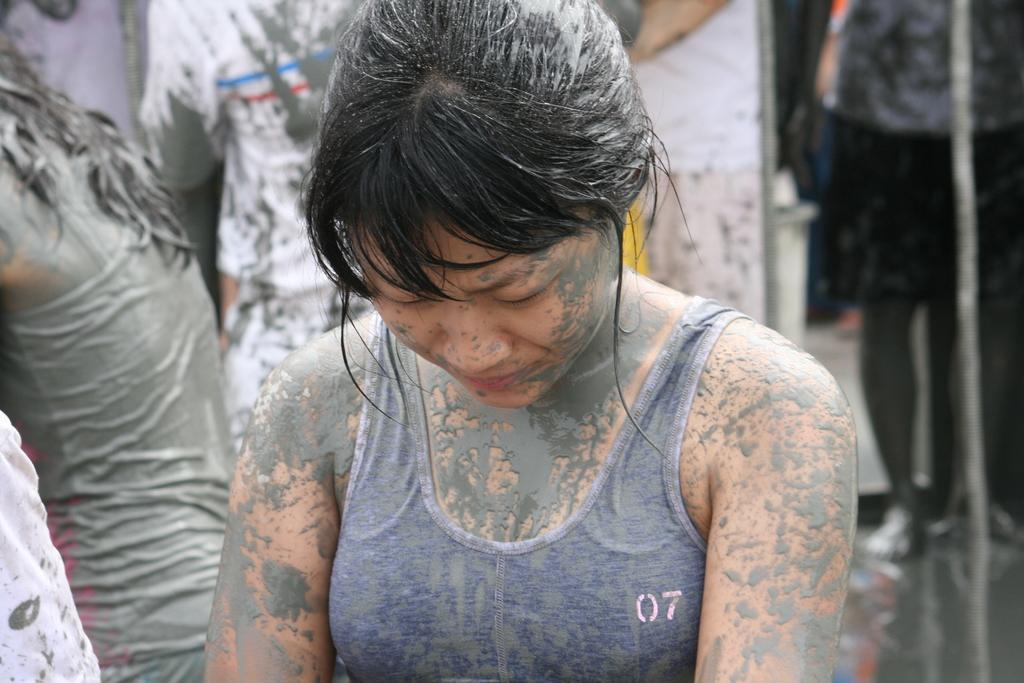How many people are in the image? There is a group of people in the image. Can you describe the attire of one person in the group? One person in the group is wearing a gray dress. What type of moon can be seen in the image? There is no moon present in the image. What is the spoon used for in the image? There is no spoon present in the image. 